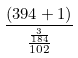<formula> <loc_0><loc_0><loc_500><loc_500>\frac { ( 3 9 4 + 1 ) } { \frac { \frac { 3 } { 1 8 4 } } { 1 0 2 } }</formula> 